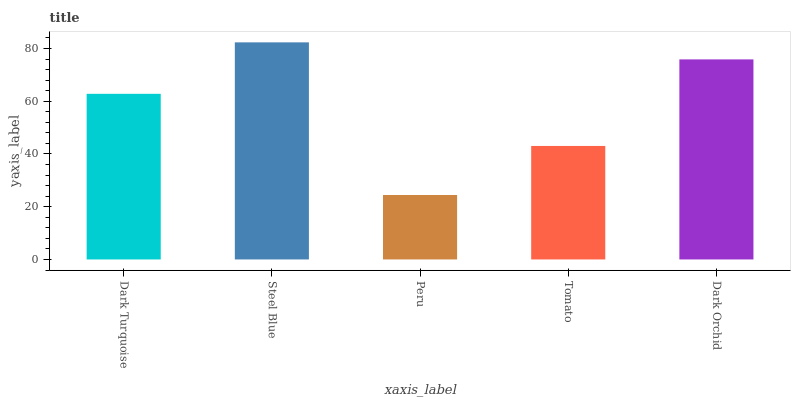Is Peru the minimum?
Answer yes or no. Yes. Is Steel Blue the maximum?
Answer yes or no. Yes. Is Steel Blue the minimum?
Answer yes or no. No. Is Peru the maximum?
Answer yes or no. No. Is Steel Blue greater than Peru?
Answer yes or no. Yes. Is Peru less than Steel Blue?
Answer yes or no. Yes. Is Peru greater than Steel Blue?
Answer yes or no. No. Is Steel Blue less than Peru?
Answer yes or no. No. Is Dark Turquoise the high median?
Answer yes or no. Yes. Is Dark Turquoise the low median?
Answer yes or no. Yes. Is Tomato the high median?
Answer yes or no. No. Is Steel Blue the low median?
Answer yes or no. No. 